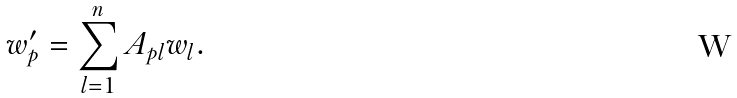<formula> <loc_0><loc_0><loc_500><loc_500>w _ { p } ^ { \prime } = \sum _ { l = 1 } ^ { n } A _ { p l } w _ { l } .</formula> 